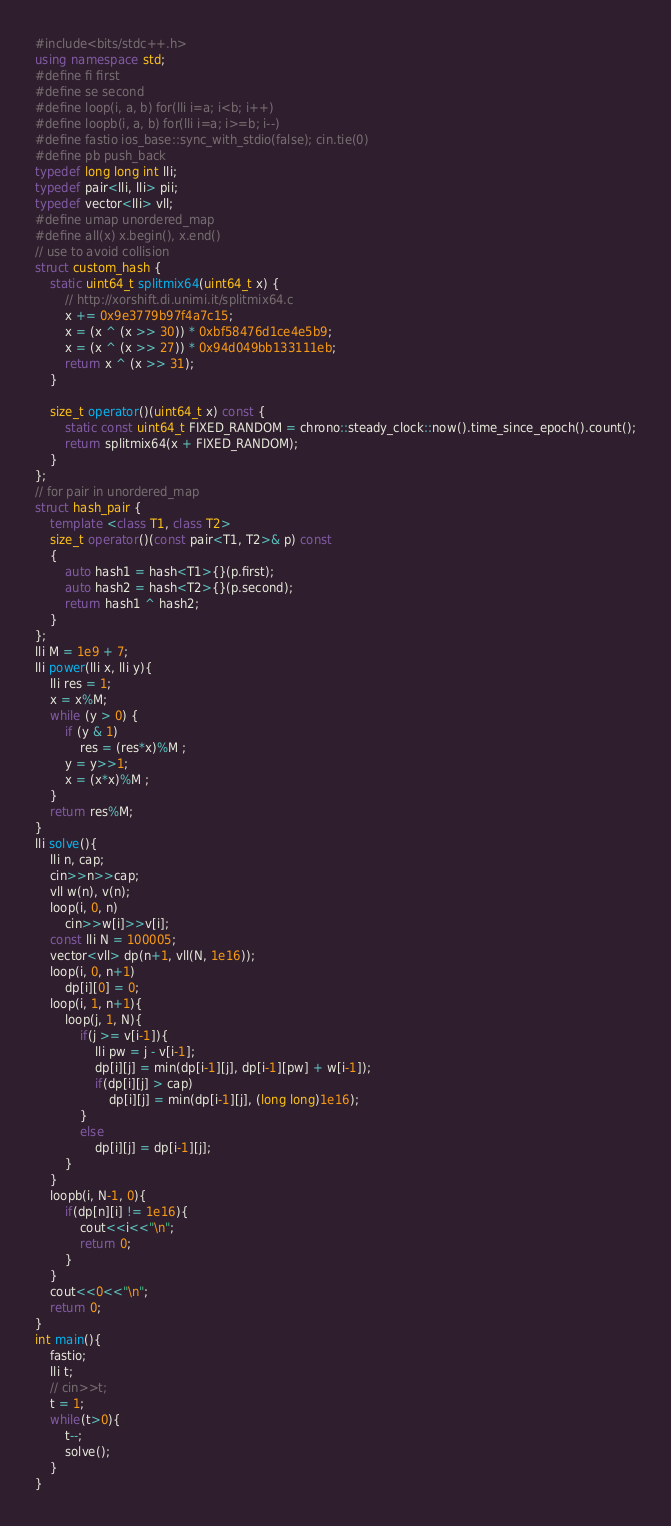Convert code to text. <code><loc_0><loc_0><loc_500><loc_500><_C++_>#include<bits/stdc++.h>
using namespace std;
#define fi first
#define se second
#define loop(i, a, b) for(lli i=a; i<b; i++)
#define loopb(i, a, b) for(lli i=a; i>=b; i--)
#define fastio ios_base::sync_with_stdio(false); cin.tie(0)
#define pb push_back
typedef long long int lli;
typedef pair<lli, lli> pii;
typedef vector<lli> vll;
#define umap unordered_map
#define all(x) x.begin(), x.end()
// use to avoid collision
struct custom_hash {
    static uint64_t splitmix64(uint64_t x) {
        // http://xorshift.di.unimi.it/splitmix64.c
        x += 0x9e3779b97f4a7c15;
        x = (x ^ (x >> 30)) * 0xbf58476d1ce4e5b9;
        x = (x ^ (x >> 27)) * 0x94d049bb133111eb;
        return x ^ (x >> 31);
    }

    size_t operator()(uint64_t x) const {
        static const uint64_t FIXED_RANDOM = chrono::steady_clock::now().time_since_epoch().count();
        return splitmix64(x + FIXED_RANDOM);
    }
};
// for pair in unordered_map
struct hash_pair {
    template <class T1, class T2>
    size_t operator()(const pair<T1, T2>& p) const
    {
        auto hash1 = hash<T1>{}(p.first);
        auto hash2 = hash<T2>{}(p.second);
        return hash1 ^ hash2;
    }
};
lli M = 1e9 + 7;
lli power(lli x, lli y){
    lli res = 1;
    x = x%M;
    while (y > 0) {
        if (y & 1)
            res = (res*x)%M ;
        y = y>>1;
        x = (x*x)%M ;
    }
    return res%M;
}
lli solve(){
    lli n, cap;
    cin>>n>>cap;
    vll w(n), v(n);
    loop(i, 0, n)
        cin>>w[i]>>v[i];
    const lli N = 100005;
    vector<vll> dp(n+1, vll(N, 1e16));
    loop(i, 0, n+1)
        dp[i][0] = 0;
    loop(i, 1, n+1){
        loop(j, 1, N){
            if(j >= v[i-1]){
                lli pw = j - v[i-1];
                dp[i][j] = min(dp[i-1][j], dp[i-1][pw] + w[i-1]);
                if(dp[i][j] > cap)
                    dp[i][j] = min(dp[i-1][j], (long long)1e16);
            }
            else
                dp[i][j] = dp[i-1][j];
        }
    }
    loopb(i, N-1, 0){
        if(dp[n][i] != 1e16){
            cout<<i<<"\n";
            return 0;
        }
    }
    cout<<0<<"\n";
    return 0;
}
int main(){
    fastio;
    lli t;
	// cin>>t;
    t = 1;
    while(t>0){ 
        t--;
        solve();
    }
}</code> 